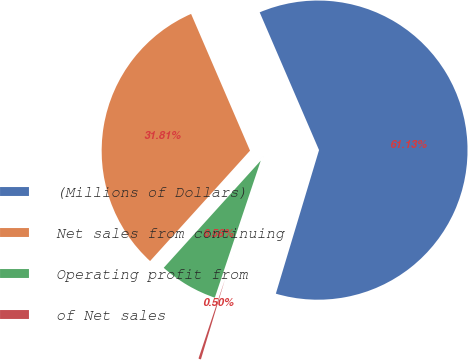Convert chart. <chart><loc_0><loc_0><loc_500><loc_500><pie_chart><fcel>(Millions of Dollars)<fcel>Net sales from continuing<fcel>Operating profit from<fcel>of Net sales<nl><fcel>61.12%<fcel>31.81%<fcel>6.56%<fcel>0.5%<nl></chart> 